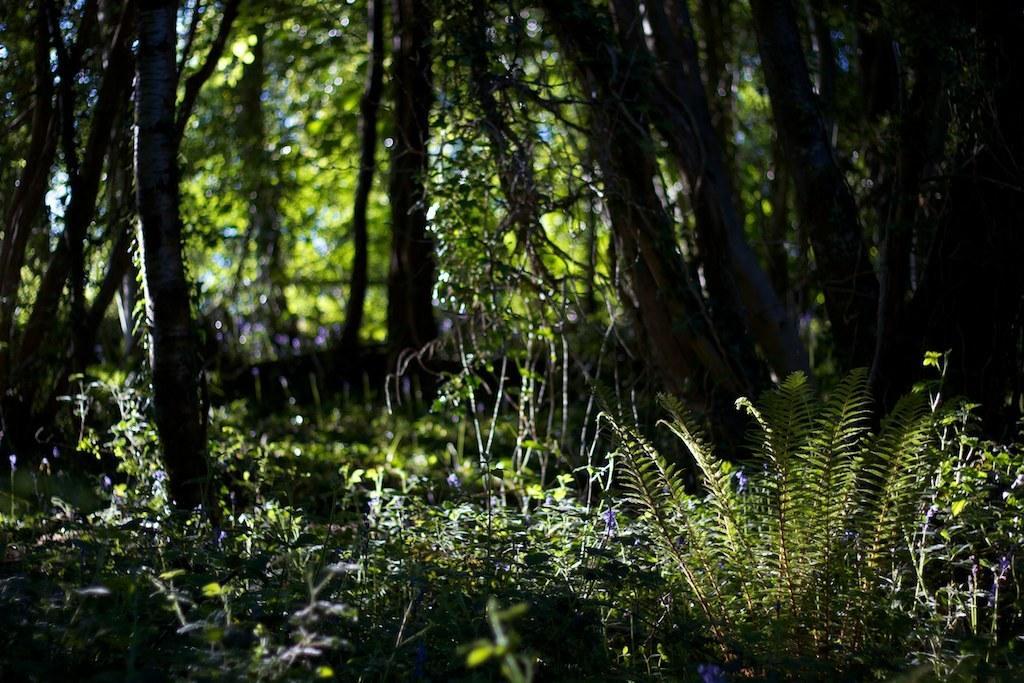Can you describe this image briefly? In this image, we can see few plants and tree trunks. Background there is a blur view. Here we can see trees. 